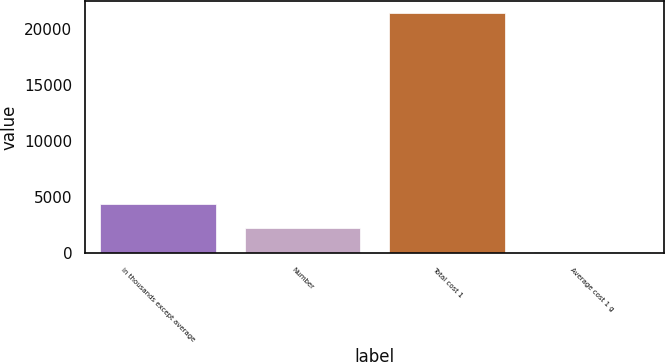Convert chart to OTSL. <chart><loc_0><loc_0><loc_500><loc_500><bar_chart><fcel>in thousands except average<fcel>Number<fcel>Total cost 1<fcel>Average cost 1 g<nl><fcel>4370.35<fcel>2232.27<fcel>21475<fcel>94.19<nl></chart> 